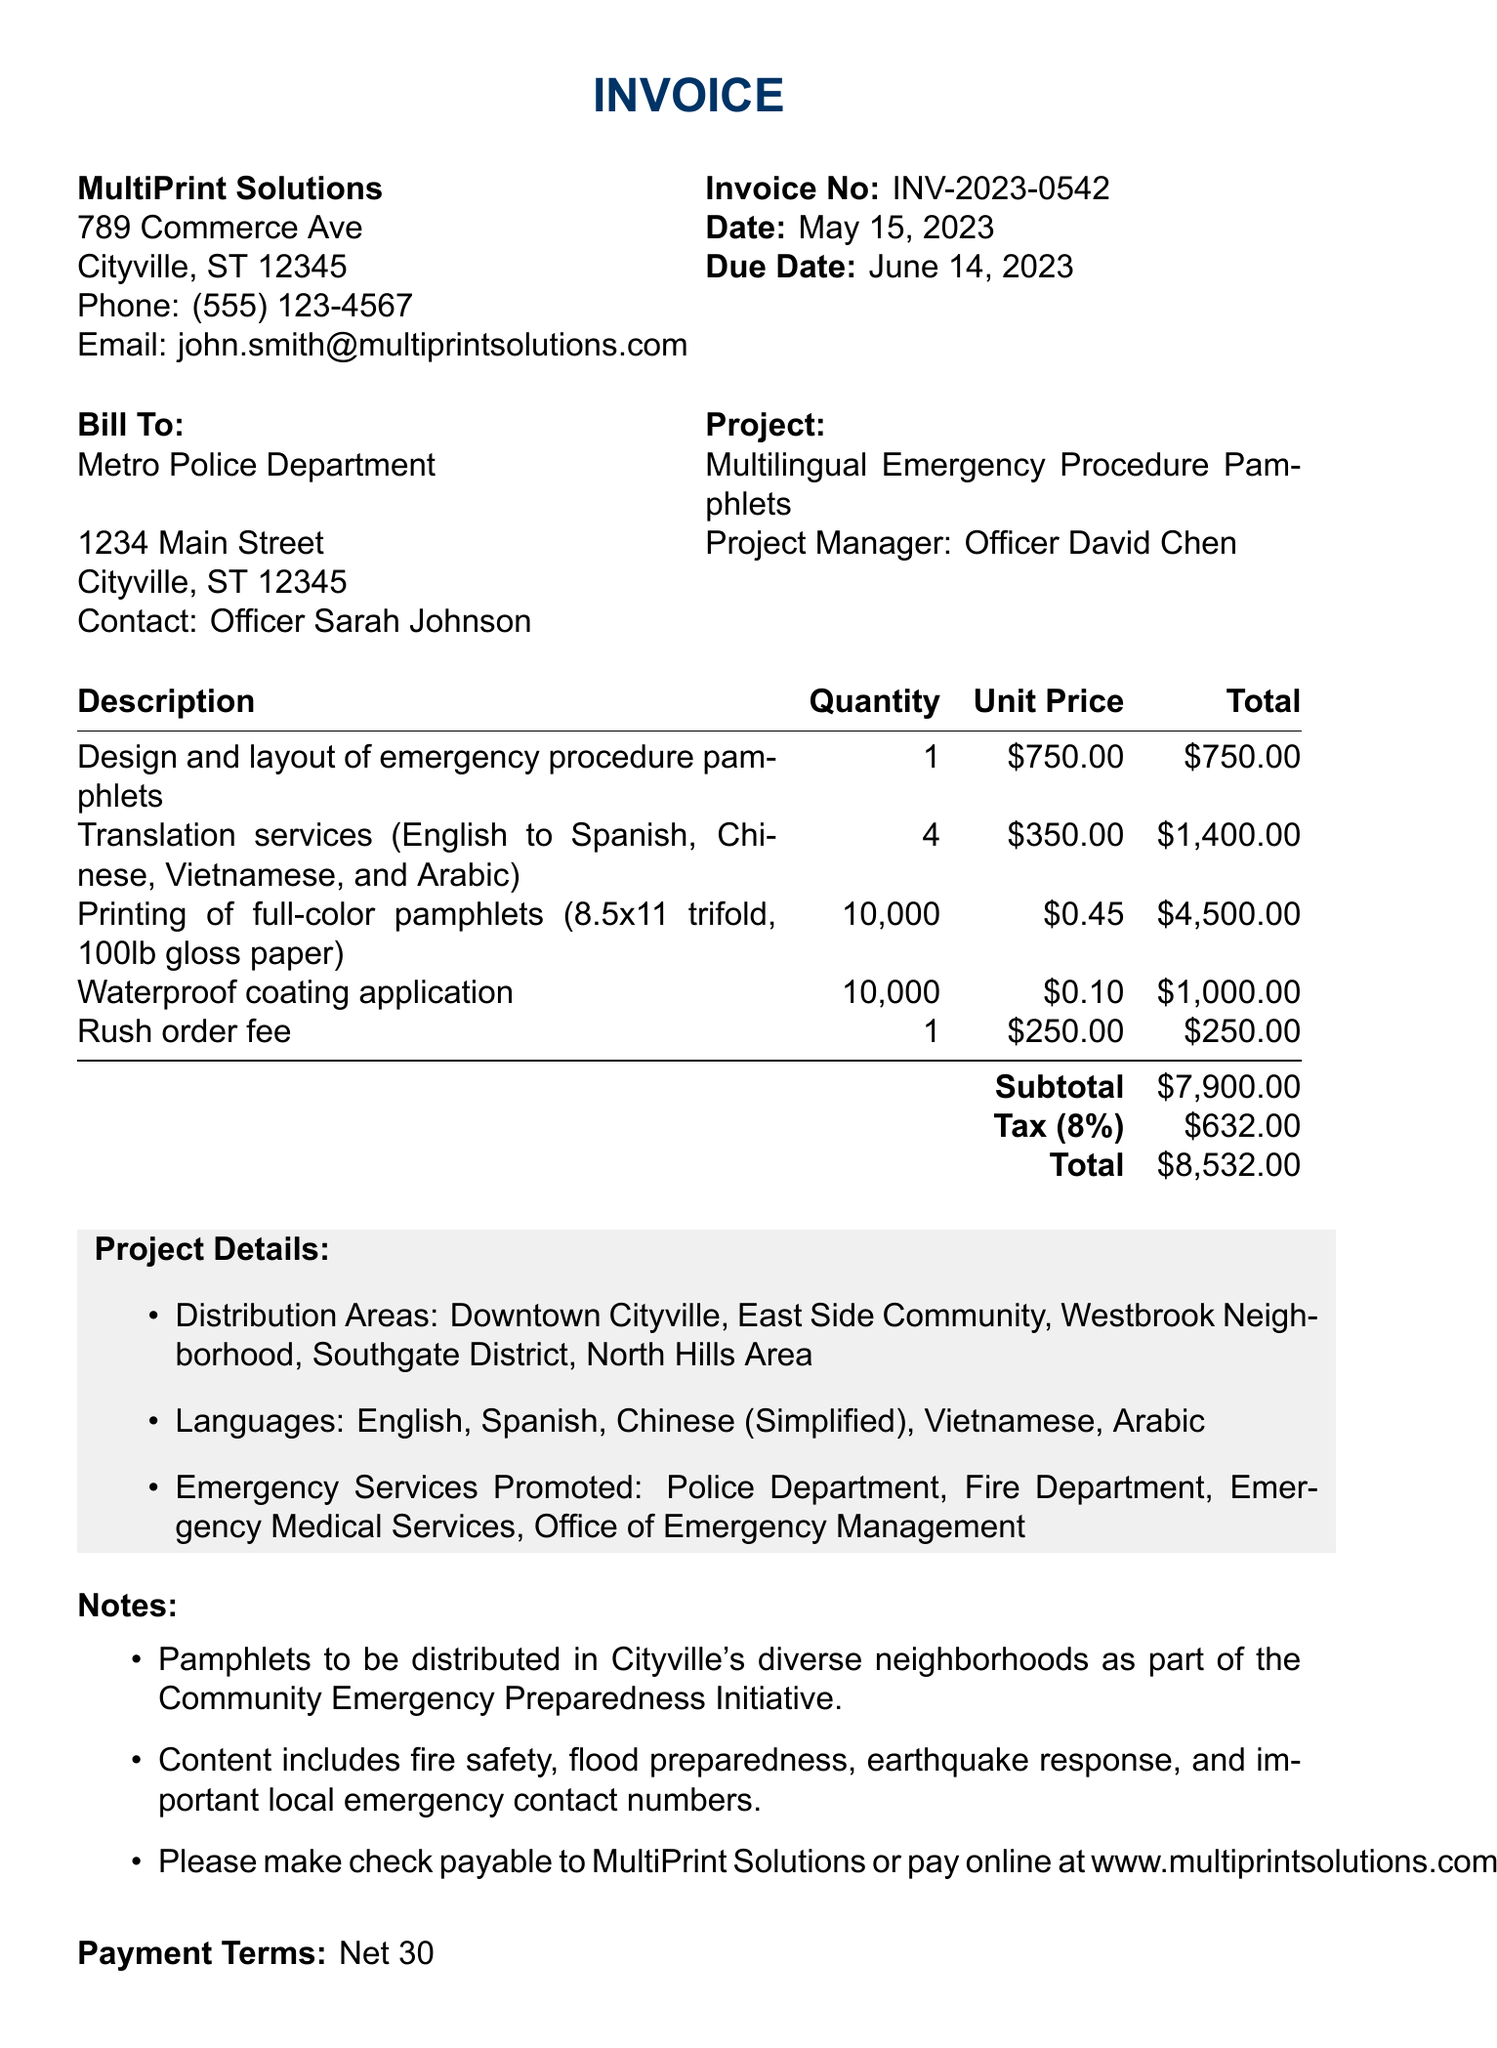What is the invoice number? The invoice number is listed under the invoice details.
Answer: INV-2023-0542 What is the due date of the invoice? The due date is specified in the invoice details section.
Answer: June 14, 2023 Who is the contact person for the vendor? The document lists a contact person for the vendor, which is John Smith.
Answer: John Smith How many languages are the pamphlets translated into? The number of languages can be calculated from the languages listed in the project details.
Answer: 5 What is the subtotal amount before tax? The subtotal is mentioned in the line items of the invoice.
Answer: $7,900.00 Which areas will the pamphlets be distributed in? The distribution areas are listed in the project details section.
Answer: Downtown Cityville, East Side Community, Westbrook Neighborhood, Southgate District, North Hills Area What fee is charged for rushing the order? The invoice specifies an additional charge for a rush order.
Answer: $250.00 What is the tax rate applied to the invoice? The tax rate can be found in the calculations of the invoice, noted as a percentage.
Answer: 8% 